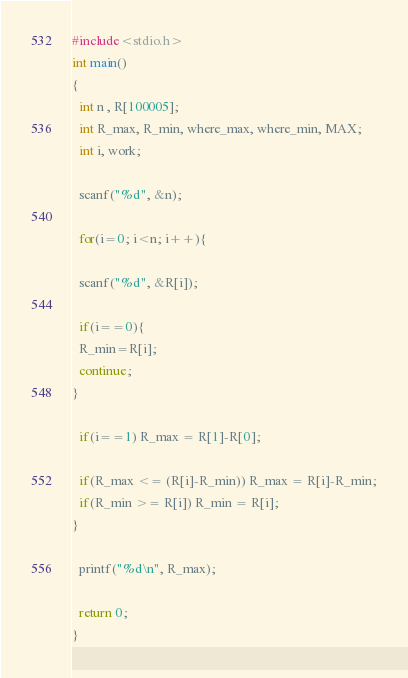Convert code to text. <code><loc_0><loc_0><loc_500><loc_500><_C_>#include<stdio.h>
int main()
{
  int n , R[100005];
  int R_max, R_min, where_max, where_min, MAX;
  int i, work;

  scanf("%d", &n);

  for(i=0; i<n; i++){

  scanf("%d", &R[i]);

  if(i==0){
  R_min=R[i];
  continue;
}

  if(i==1) R_max = R[1]-R[0];

  if(R_max <= (R[i]-R_min)) R_max = R[i]-R_min;
  if(R_min >= R[i]) R_min = R[i];
}

  printf("%d\n", R_max);

  return 0;
}</code> 